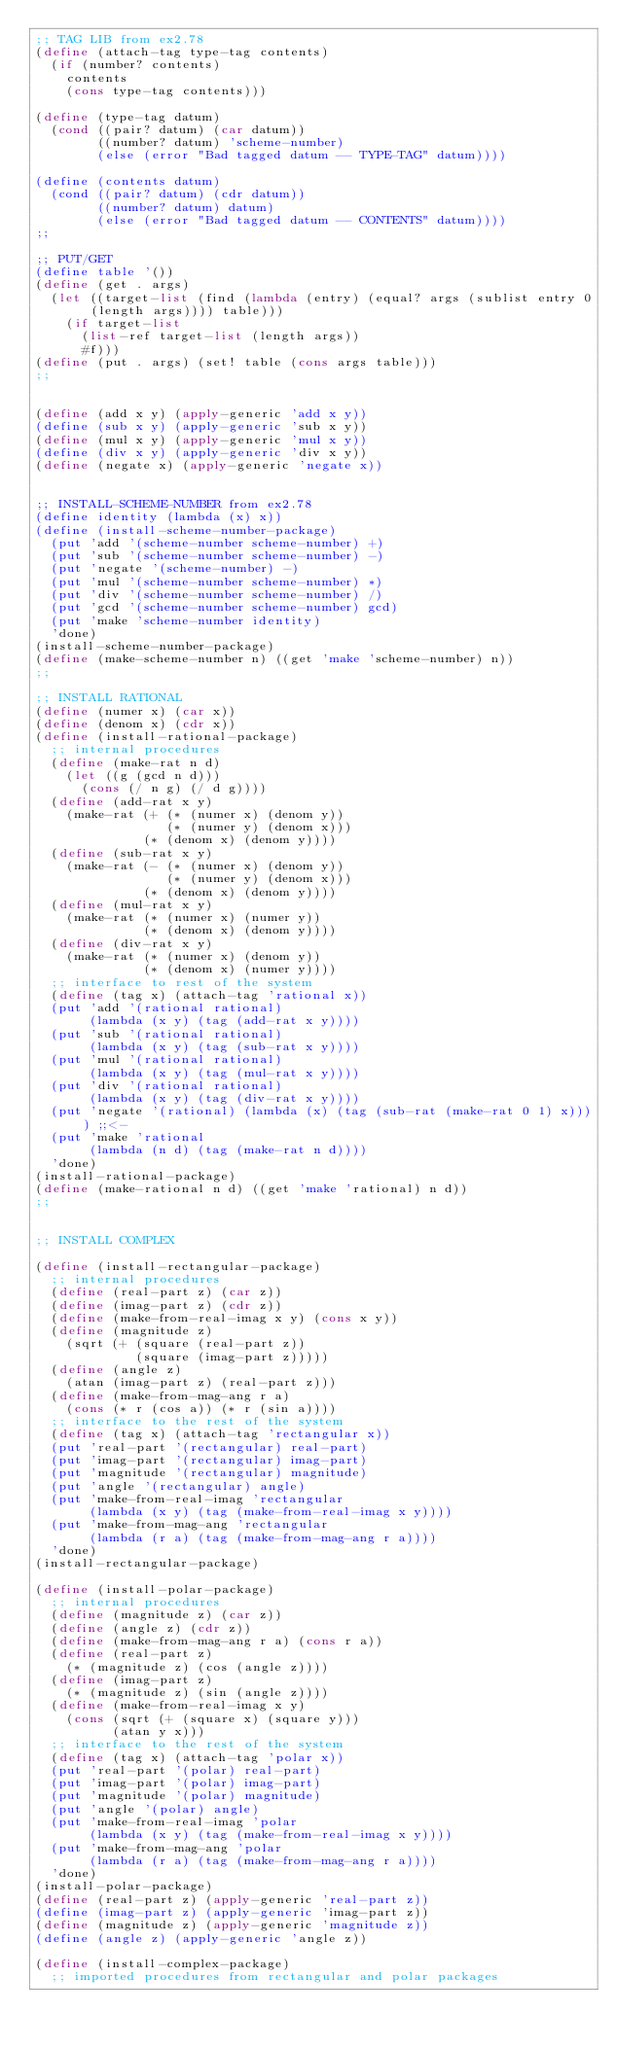<code> <loc_0><loc_0><loc_500><loc_500><_Scheme_>;; TAG LIB from ex2.78
(define (attach-tag type-tag contents)
  (if (number? contents)
    contents
    (cons type-tag contents)))

(define (type-tag datum)
  (cond ((pair? datum) (car datum))
        ((number? datum) 'scheme-number)
        (else (error "Bad tagged datum -- TYPE-TAG" datum))))

(define (contents datum)
  (cond ((pair? datum) (cdr datum))
        ((number? datum) datum)
        (else (error "Bad tagged datum -- CONTENTS" datum))))
;;

;; PUT/GET
(define table '())
(define (get . args)
  (let ((target-list (find (lambda (entry) (equal? args (sublist entry 0 (length args)))) table)))
    (if target-list
      (list-ref target-list (length args))
      #f)))
(define (put . args) (set! table (cons args table)))
;;


(define (add x y) (apply-generic 'add x y))
(define (sub x y) (apply-generic 'sub x y))
(define (mul x y) (apply-generic 'mul x y))
(define (div x y) (apply-generic 'div x y))
(define (negate x) (apply-generic 'negate x))


;; INSTALL-SCHEME-NUMBER from ex2.78
(define identity (lambda (x) x))
(define (install-scheme-number-package)
  (put 'add '(scheme-number scheme-number) +)
  (put 'sub '(scheme-number scheme-number) -)
  (put 'negate '(scheme-number) -)
  (put 'mul '(scheme-number scheme-number) *)
  (put 'div '(scheme-number scheme-number) /)
  (put 'gcd '(scheme-number scheme-number) gcd)
  (put 'make 'scheme-number identity)
  'done)
(install-scheme-number-package)
(define (make-scheme-number n) ((get 'make 'scheme-number) n))
;;

;; INSTALL RATIONAL
(define (numer x) (car x))
(define (denom x) (cdr x))
(define (install-rational-package)
  ;; internal procedures
  (define (make-rat n d)
    (let ((g (gcd n d)))
      (cons (/ n g) (/ d g))))
  (define (add-rat x y)
    (make-rat (+ (* (numer x) (denom y))
                 (* (numer y) (denom x)))
              (* (denom x) (denom y))))
  (define (sub-rat x y)
    (make-rat (- (* (numer x) (denom y))
                 (* (numer y) (denom x)))
              (* (denom x) (denom y))))
  (define (mul-rat x y)
    (make-rat (* (numer x) (numer y))
              (* (denom x) (denom y))))
  (define (div-rat x y)
    (make-rat (* (numer x) (denom y))
              (* (denom x) (numer y))))
  ;; interface to rest of the system
  (define (tag x) (attach-tag 'rational x))
  (put 'add '(rational rational)
       (lambda (x y) (tag (add-rat x y))))
  (put 'sub '(rational rational)
       (lambda (x y) (tag (sub-rat x y))))
  (put 'mul '(rational rational)
       (lambda (x y) (tag (mul-rat x y))))
  (put 'div '(rational rational)
       (lambda (x y) (tag (div-rat x y))))
  (put 'negate '(rational) (lambda (x) (tag (sub-rat (make-rat 0 1) x)))) ;;<-
  (put 'make 'rational
       (lambda (n d) (tag (make-rat n d))))
  'done)
(install-rational-package)
(define (make-rational n d) ((get 'make 'rational) n d))
;;


;; INSTALL COMPLEX

(define (install-rectangular-package)
  ;; internal procedures
  (define (real-part z) (car z))
  (define (imag-part z) (cdr z))
  (define (make-from-real-imag x y) (cons x y))
  (define (magnitude z)
    (sqrt (+ (square (real-part z))
             (square (imag-part z)))))
  (define (angle z)
    (atan (imag-part z) (real-part z)))
  (define (make-from-mag-ang r a) 
    (cons (* r (cos a)) (* r (sin a))))
  ;; interface to the rest of the system
  (define (tag x) (attach-tag 'rectangular x))
  (put 'real-part '(rectangular) real-part)
  (put 'imag-part '(rectangular) imag-part)
  (put 'magnitude '(rectangular) magnitude)
  (put 'angle '(rectangular) angle)
  (put 'make-from-real-imag 'rectangular 
       (lambda (x y) (tag (make-from-real-imag x y))))
  (put 'make-from-mag-ang 'rectangular 
       (lambda (r a) (tag (make-from-mag-ang r a))))
  'done)
(install-rectangular-package)

(define (install-polar-package)
  ;; internal procedures
  (define (magnitude z) (car z))
  (define (angle z) (cdr z))
  (define (make-from-mag-ang r a) (cons r a))
  (define (real-part z)
    (* (magnitude z) (cos (angle z))))
  (define (imag-part z)
    (* (magnitude z) (sin (angle z))))
  (define (make-from-real-imag x y) 
    (cons (sqrt (+ (square x) (square y)))
          (atan y x)))
  ;; interface to the rest of the system
  (define (tag x) (attach-tag 'polar x))
  (put 'real-part '(polar) real-part)
  (put 'imag-part '(polar) imag-part)
  (put 'magnitude '(polar) magnitude)
  (put 'angle '(polar) angle)
  (put 'make-from-real-imag 'polar
       (lambda (x y) (tag (make-from-real-imag x y))))
  (put 'make-from-mag-ang 'polar 
       (lambda (r a) (tag (make-from-mag-ang r a))))
  'done)
(install-polar-package)
(define (real-part z) (apply-generic 'real-part z))
(define (imag-part z) (apply-generic 'imag-part z))
(define (magnitude z) (apply-generic 'magnitude z))
(define (angle z) (apply-generic 'angle z))

(define (install-complex-package)
  ;; imported procedures from rectangular and polar packages</code> 